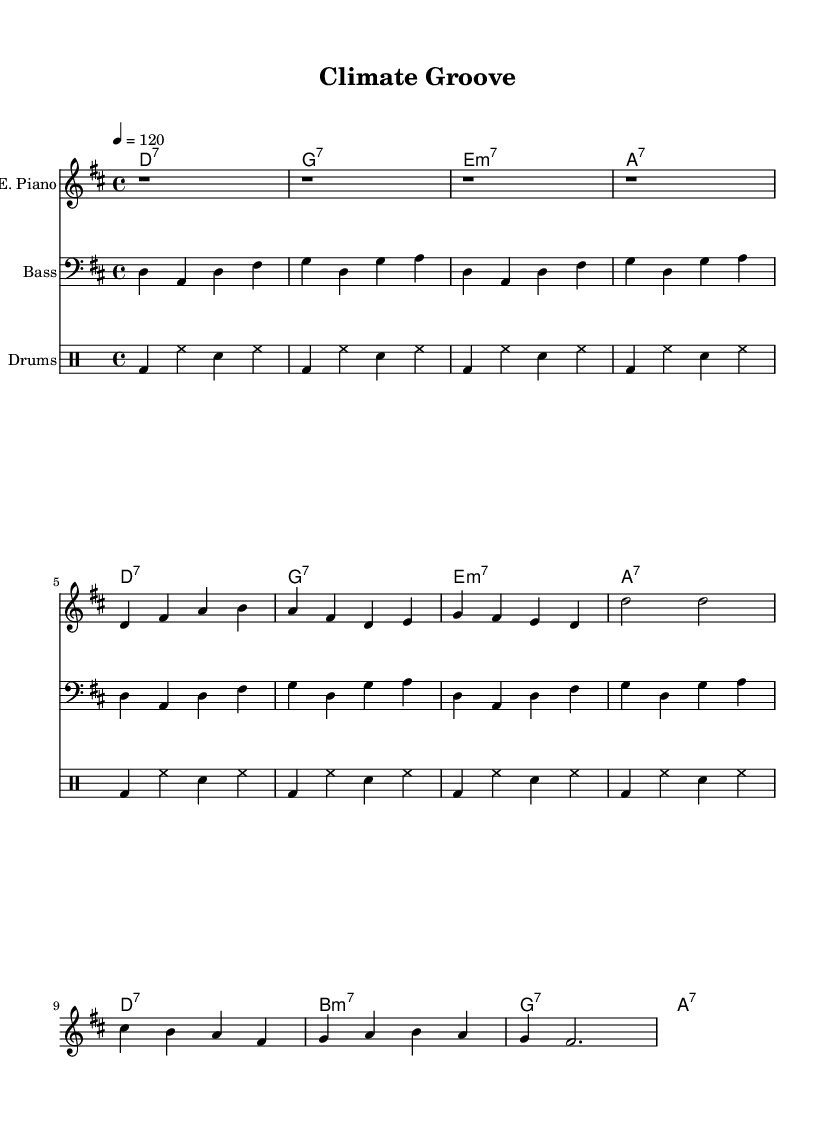What is the key signature of this music? The key signature is D major, which has two sharps (F# and C#). This can be identified by looking at the key signature marking at the beginning of the staff.
Answer: D major What is the time signature of this music? The time signature is 4/4, as indicated at the beginning of the score. This means there are four beats in a measure and the quarter note gets one beat.
Answer: 4/4 What is the tempo marking for this piece? The tempo marking indicates a tempo of 120 beats per minute, indicated by the marking "4 = 120" at the beginning of the score. This specifies the speed at which the piece should be played.
Answer: 120 How many measures are there in the electric piano part? The electric piano part contains eight measures. This can be determined by counting the measures (separated by the vertical lines) in the provided electric piano notation.
Answer: Eight What type of chord is played in the first measure? The first measure features a D7 chord, as identified by the chord names above the electric piano staff, specifically the notation "d1:7" indicates a D dominant seventh chord.
Answer: D7 Why does the bass guitar repeat the same pattern throughout the piece? The bass guitar part consistently plays a repeating rhythmic pattern which is characteristic of funk-influenced R&B music, providing a steady groove that supports the harmonic structure. This repetition enhances the song's feel and emphasizes the upbeat nature of the track.
Answer: Repeating pattern 